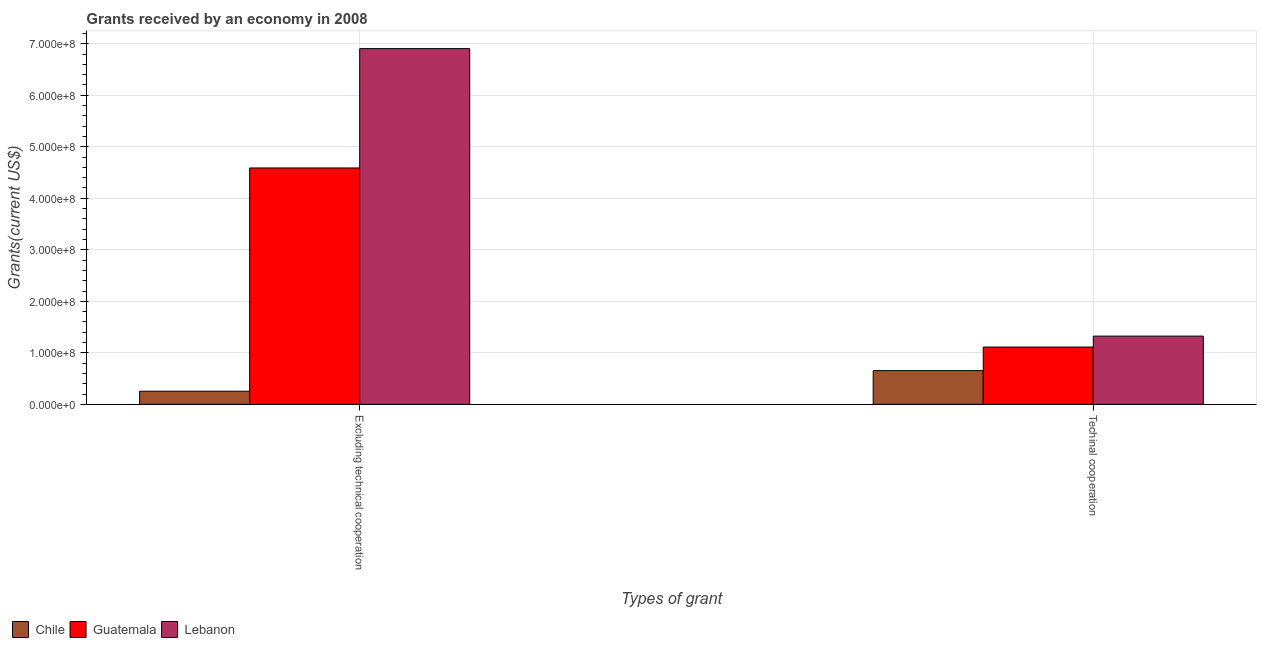How many groups of bars are there?
Provide a succinct answer. 2. Are the number of bars per tick equal to the number of legend labels?
Your response must be concise. Yes. Are the number of bars on each tick of the X-axis equal?
Give a very brief answer. Yes. How many bars are there on the 2nd tick from the left?
Offer a terse response. 3. What is the label of the 2nd group of bars from the left?
Offer a very short reply. Techinal cooperation. What is the amount of grants received(including technical cooperation) in Chile?
Offer a very short reply. 6.55e+07. Across all countries, what is the maximum amount of grants received(excluding technical cooperation)?
Your response must be concise. 6.90e+08. Across all countries, what is the minimum amount of grants received(excluding technical cooperation)?
Your answer should be compact. 2.55e+07. In which country was the amount of grants received(including technical cooperation) maximum?
Keep it short and to the point. Lebanon. In which country was the amount of grants received(including technical cooperation) minimum?
Give a very brief answer. Chile. What is the total amount of grants received(excluding technical cooperation) in the graph?
Offer a very short reply. 1.17e+09. What is the difference between the amount of grants received(including technical cooperation) in Lebanon and that in Guatemala?
Your answer should be compact. 2.13e+07. What is the difference between the amount of grants received(including technical cooperation) in Guatemala and the amount of grants received(excluding technical cooperation) in Lebanon?
Offer a terse response. -5.79e+08. What is the average amount of grants received(excluding technical cooperation) per country?
Offer a very short reply. 3.92e+08. What is the difference between the amount of grants received(excluding technical cooperation) and amount of grants received(including technical cooperation) in Lebanon?
Your answer should be compact. 5.58e+08. In how many countries, is the amount of grants received(including technical cooperation) greater than 40000000 US$?
Give a very brief answer. 3. What is the ratio of the amount of grants received(excluding technical cooperation) in Guatemala to that in Chile?
Make the answer very short. 17.97. Is the amount of grants received(including technical cooperation) in Guatemala less than that in Chile?
Offer a terse response. No. What does the 3rd bar from the left in Excluding technical cooperation represents?
Your answer should be compact. Lebanon. How many bars are there?
Keep it short and to the point. 6. Are all the bars in the graph horizontal?
Offer a terse response. No. How many countries are there in the graph?
Offer a terse response. 3. Does the graph contain any zero values?
Make the answer very short. No. How many legend labels are there?
Provide a short and direct response. 3. How are the legend labels stacked?
Keep it short and to the point. Horizontal. What is the title of the graph?
Provide a short and direct response. Grants received by an economy in 2008. What is the label or title of the X-axis?
Provide a short and direct response. Types of grant. What is the label or title of the Y-axis?
Your answer should be compact. Grants(current US$). What is the Grants(current US$) in Chile in Excluding technical cooperation?
Your answer should be very brief. 2.55e+07. What is the Grants(current US$) of Guatemala in Excluding technical cooperation?
Ensure brevity in your answer.  4.59e+08. What is the Grants(current US$) of Lebanon in Excluding technical cooperation?
Make the answer very short. 6.90e+08. What is the Grants(current US$) in Chile in Techinal cooperation?
Offer a terse response. 6.55e+07. What is the Grants(current US$) in Guatemala in Techinal cooperation?
Your response must be concise. 1.11e+08. What is the Grants(current US$) of Lebanon in Techinal cooperation?
Provide a short and direct response. 1.32e+08. Across all Types of grant, what is the maximum Grants(current US$) in Chile?
Offer a terse response. 6.55e+07. Across all Types of grant, what is the maximum Grants(current US$) in Guatemala?
Provide a succinct answer. 4.59e+08. Across all Types of grant, what is the maximum Grants(current US$) of Lebanon?
Offer a terse response. 6.90e+08. Across all Types of grant, what is the minimum Grants(current US$) in Chile?
Offer a terse response. 2.55e+07. Across all Types of grant, what is the minimum Grants(current US$) in Guatemala?
Your answer should be very brief. 1.11e+08. Across all Types of grant, what is the minimum Grants(current US$) in Lebanon?
Your response must be concise. 1.32e+08. What is the total Grants(current US$) of Chile in the graph?
Your answer should be very brief. 9.10e+07. What is the total Grants(current US$) of Guatemala in the graph?
Ensure brevity in your answer.  5.70e+08. What is the total Grants(current US$) of Lebanon in the graph?
Provide a short and direct response. 8.23e+08. What is the difference between the Grants(current US$) of Chile in Excluding technical cooperation and that in Techinal cooperation?
Your response must be concise. -3.99e+07. What is the difference between the Grants(current US$) in Guatemala in Excluding technical cooperation and that in Techinal cooperation?
Give a very brief answer. 3.48e+08. What is the difference between the Grants(current US$) of Lebanon in Excluding technical cooperation and that in Techinal cooperation?
Give a very brief answer. 5.58e+08. What is the difference between the Grants(current US$) in Chile in Excluding technical cooperation and the Grants(current US$) in Guatemala in Techinal cooperation?
Provide a short and direct response. -8.57e+07. What is the difference between the Grants(current US$) of Chile in Excluding technical cooperation and the Grants(current US$) of Lebanon in Techinal cooperation?
Your response must be concise. -1.07e+08. What is the difference between the Grants(current US$) of Guatemala in Excluding technical cooperation and the Grants(current US$) of Lebanon in Techinal cooperation?
Ensure brevity in your answer.  3.26e+08. What is the average Grants(current US$) in Chile per Types of grant?
Provide a short and direct response. 4.55e+07. What is the average Grants(current US$) in Guatemala per Types of grant?
Give a very brief answer. 2.85e+08. What is the average Grants(current US$) in Lebanon per Types of grant?
Offer a very short reply. 4.11e+08. What is the difference between the Grants(current US$) of Chile and Grants(current US$) of Guatemala in Excluding technical cooperation?
Give a very brief answer. -4.33e+08. What is the difference between the Grants(current US$) in Chile and Grants(current US$) in Lebanon in Excluding technical cooperation?
Keep it short and to the point. -6.65e+08. What is the difference between the Grants(current US$) in Guatemala and Grants(current US$) in Lebanon in Excluding technical cooperation?
Make the answer very short. -2.32e+08. What is the difference between the Grants(current US$) in Chile and Grants(current US$) in Guatemala in Techinal cooperation?
Provide a short and direct response. -4.58e+07. What is the difference between the Grants(current US$) of Chile and Grants(current US$) of Lebanon in Techinal cooperation?
Provide a short and direct response. -6.70e+07. What is the difference between the Grants(current US$) of Guatemala and Grants(current US$) of Lebanon in Techinal cooperation?
Give a very brief answer. -2.13e+07. What is the ratio of the Grants(current US$) in Chile in Excluding technical cooperation to that in Techinal cooperation?
Ensure brevity in your answer.  0.39. What is the ratio of the Grants(current US$) of Guatemala in Excluding technical cooperation to that in Techinal cooperation?
Make the answer very short. 4.13. What is the ratio of the Grants(current US$) in Lebanon in Excluding technical cooperation to that in Techinal cooperation?
Provide a succinct answer. 5.21. What is the difference between the highest and the second highest Grants(current US$) of Chile?
Offer a very short reply. 3.99e+07. What is the difference between the highest and the second highest Grants(current US$) in Guatemala?
Offer a very short reply. 3.48e+08. What is the difference between the highest and the second highest Grants(current US$) in Lebanon?
Offer a very short reply. 5.58e+08. What is the difference between the highest and the lowest Grants(current US$) of Chile?
Offer a terse response. 3.99e+07. What is the difference between the highest and the lowest Grants(current US$) of Guatemala?
Ensure brevity in your answer.  3.48e+08. What is the difference between the highest and the lowest Grants(current US$) of Lebanon?
Make the answer very short. 5.58e+08. 